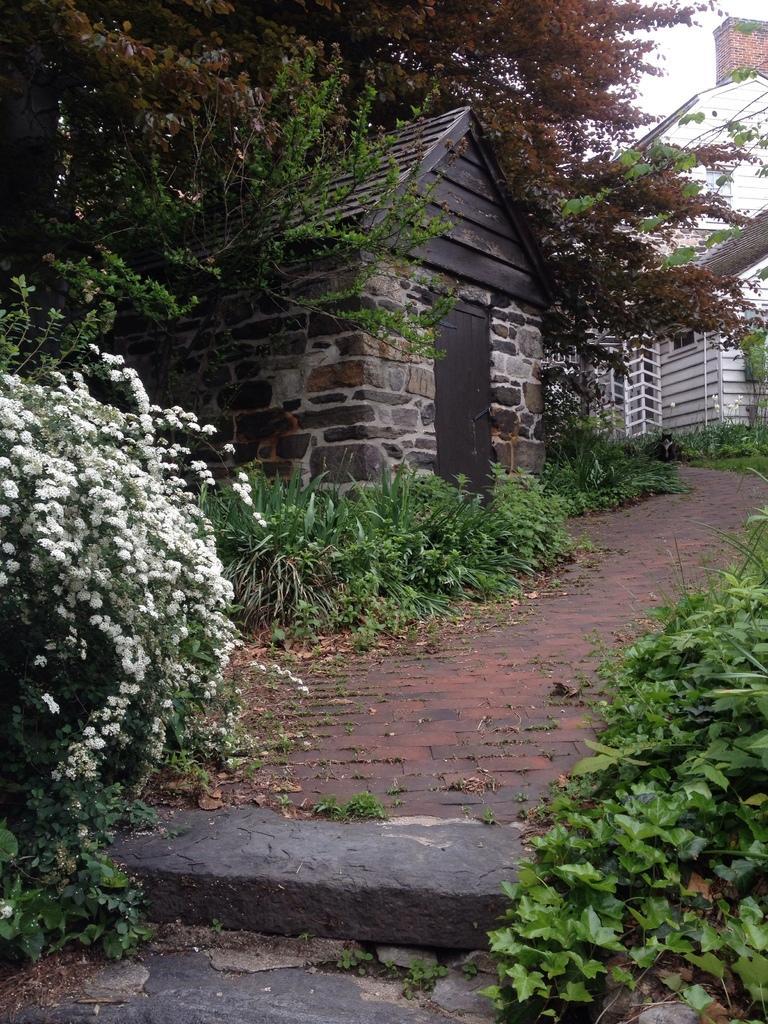Describe this image in one or two sentences. In this picture we can see flowers, plants, patio, door, trees, buildings and in the background we can see the sky. 